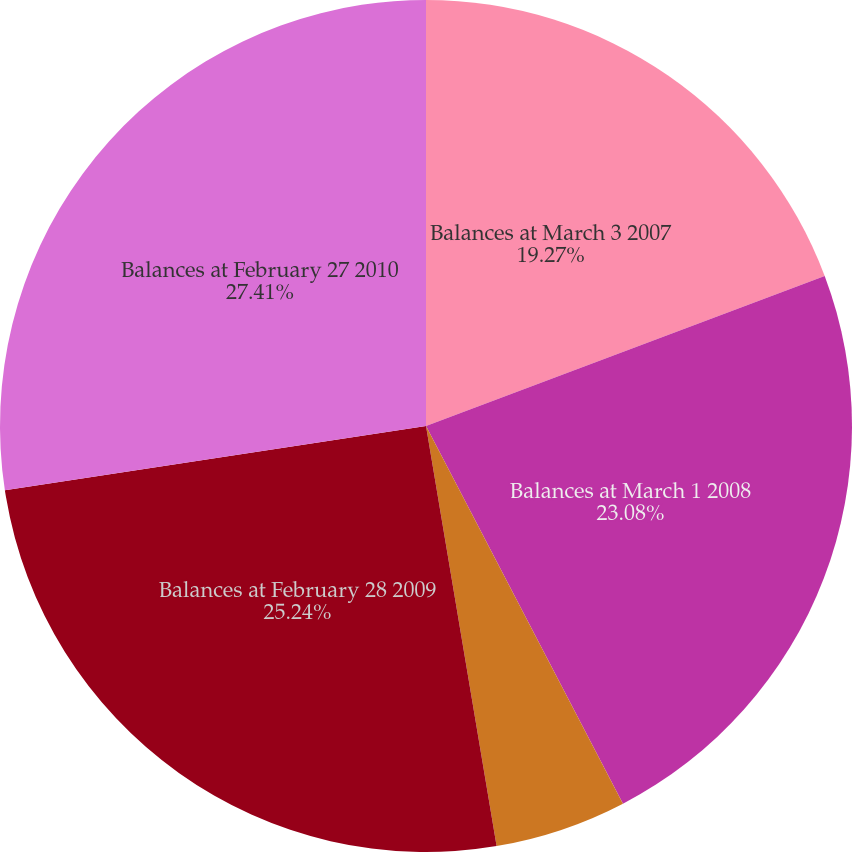Convert chart to OTSL. <chart><loc_0><loc_0><loc_500><loc_500><pie_chart><fcel>Balances at March 3 2007<fcel>Balances at March 1 2008<fcel>Acquisitions<fcel>Balances at February 28 2009<fcel>Balances at February 27 2010<nl><fcel>19.27%<fcel>23.08%<fcel>5.0%<fcel>25.24%<fcel>27.41%<nl></chart> 